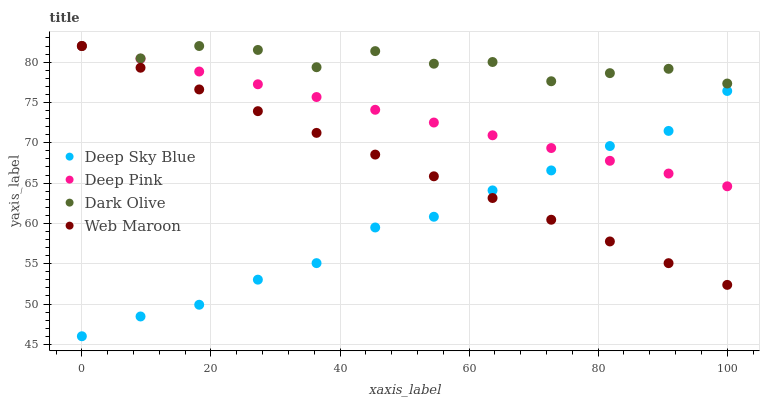Does Deep Sky Blue have the minimum area under the curve?
Answer yes or no. Yes. Does Dark Olive have the maximum area under the curve?
Answer yes or no. Yes. Does Deep Pink have the minimum area under the curve?
Answer yes or no. No. Does Deep Pink have the maximum area under the curve?
Answer yes or no. No. Is Deep Pink the smoothest?
Answer yes or no. Yes. Is Dark Olive the roughest?
Answer yes or no. Yes. Is Web Maroon the smoothest?
Answer yes or no. No. Is Web Maroon the roughest?
Answer yes or no. No. Does Deep Sky Blue have the lowest value?
Answer yes or no. Yes. Does Deep Pink have the lowest value?
Answer yes or no. No. Does Web Maroon have the highest value?
Answer yes or no. Yes. Does Deep Sky Blue have the highest value?
Answer yes or no. No. Is Deep Sky Blue less than Dark Olive?
Answer yes or no. Yes. Is Dark Olive greater than Deep Sky Blue?
Answer yes or no. Yes. Does Dark Olive intersect Web Maroon?
Answer yes or no. Yes. Is Dark Olive less than Web Maroon?
Answer yes or no. No. Is Dark Olive greater than Web Maroon?
Answer yes or no. No. Does Deep Sky Blue intersect Dark Olive?
Answer yes or no. No. 